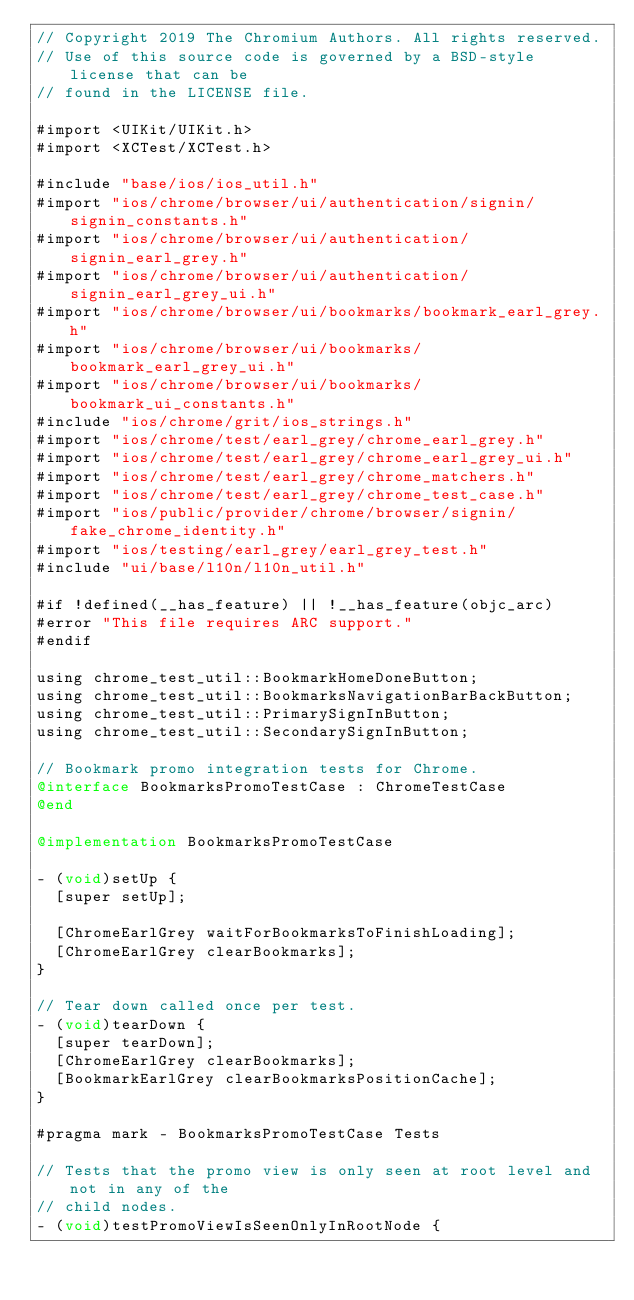<code> <loc_0><loc_0><loc_500><loc_500><_ObjectiveC_>// Copyright 2019 The Chromium Authors. All rights reserved.
// Use of this source code is governed by a BSD-style license that can be
// found in the LICENSE file.

#import <UIKit/UIKit.h>
#import <XCTest/XCTest.h>

#include "base/ios/ios_util.h"
#import "ios/chrome/browser/ui/authentication/signin/signin_constants.h"
#import "ios/chrome/browser/ui/authentication/signin_earl_grey.h"
#import "ios/chrome/browser/ui/authentication/signin_earl_grey_ui.h"
#import "ios/chrome/browser/ui/bookmarks/bookmark_earl_grey.h"
#import "ios/chrome/browser/ui/bookmarks/bookmark_earl_grey_ui.h"
#import "ios/chrome/browser/ui/bookmarks/bookmark_ui_constants.h"
#include "ios/chrome/grit/ios_strings.h"
#import "ios/chrome/test/earl_grey/chrome_earl_grey.h"
#import "ios/chrome/test/earl_grey/chrome_earl_grey_ui.h"
#import "ios/chrome/test/earl_grey/chrome_matchers.h"
#import "ios/chrome/test/earl_grey/chrome_test_case.h"
#import "ios/public/provider/chrome/browser/signin/fake_chrome_identity.h"
#import "ios/testing/earl_grey/earl_grey_test.h"
#include "ui/base/l10n/l10n_util.h"

#if !defined(__has_feature) || !__has_feature(objc_arc)
#error "This file requires ARC support."
#endif

using chrome_test_util::BookmarkHomeDoneButton;
using chrome_test_util::BookmarksNavigationBarBackButton;
using chrome_test_util::PrimarySignInButton;
using chrome_test_util::SecondarySignInButton;

// Bookmark promo integration tests for Chrome.
@interface BookmarksPromoTestCase : ChromeTestCase
@end

@implementation BookmarksPromoTestCase

- (void)setUp {
  [super setUp];

  [ChromeEarlGrey waitForBookmarksToFinishLoading];
  [ChromeEarlGrey clearBookmarks];
}

// Tear down called once per test.
- (void)tearDown {
  [super tearDown];
  [ChromeEarlGrey clearBookmarks];
  [BookmarkEarlGrey clearBookmarksPositionCache];
}

#pragma mark - BookmarksPromoTestCase Tests

// Tests that the promo view is only seen at root level and not in any of the
// child nodes.
- (void)testPromoViewIsSeenOnlyInRootNode {</code> 